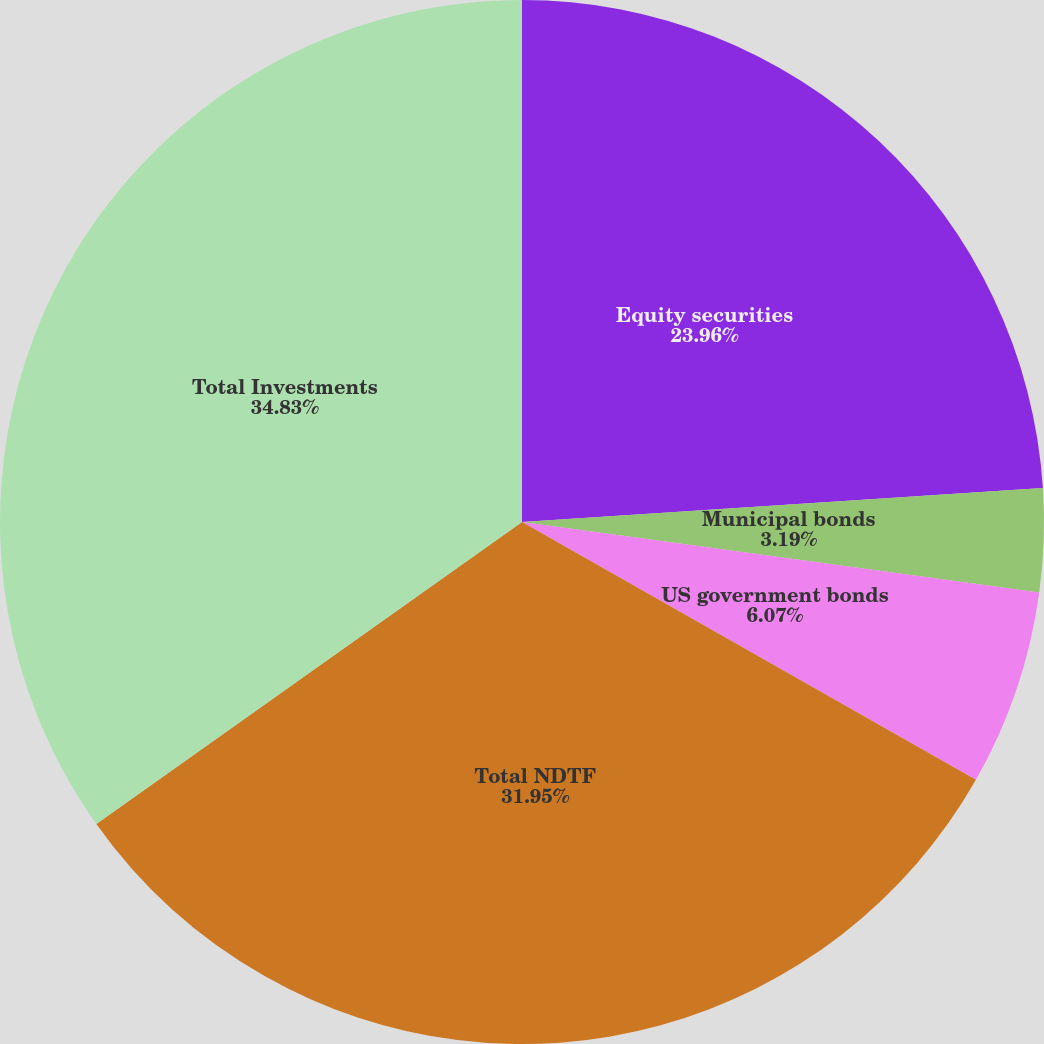<chart> <loc_0><loc_0><loc_500><loc_500><pie_chart><fcel>Equity securities<fcel>Municipal bonds<fcel>US government bonds<fcel>Total NDTF<fcel>Total Investments<nl><fcel>23.96%<fcel>3.19%<fcel>6.07%<fcel>31.95%<fcel>34.82%<nl></chart> 